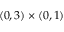<formula> <loc_0><loc_0><loc_500><loc_500>( 0 , 3 ) \times ( 0 , 1 )</formula> 